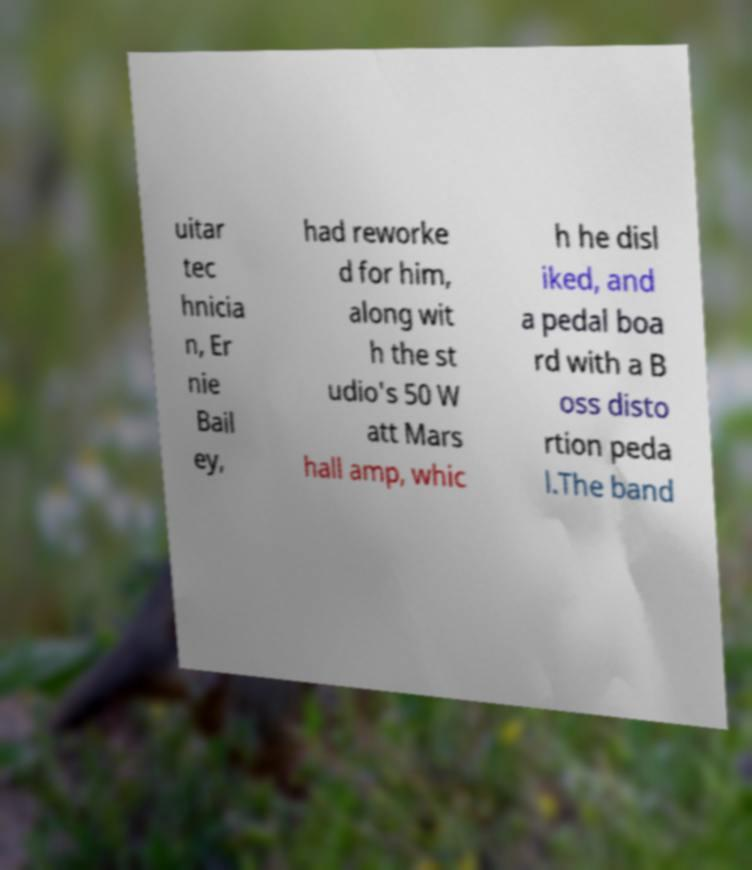There's text embedded in this image that I need extracted. Can you transcribe it verbatim? uitar tec hnicia n, Er nie Bail ey, had reworke d for him, along wit h the st udio's 50 W att Mars hall amp, whic h he disl iked, and a pedal boa rd with a B oss disto rtion peda l.The band 